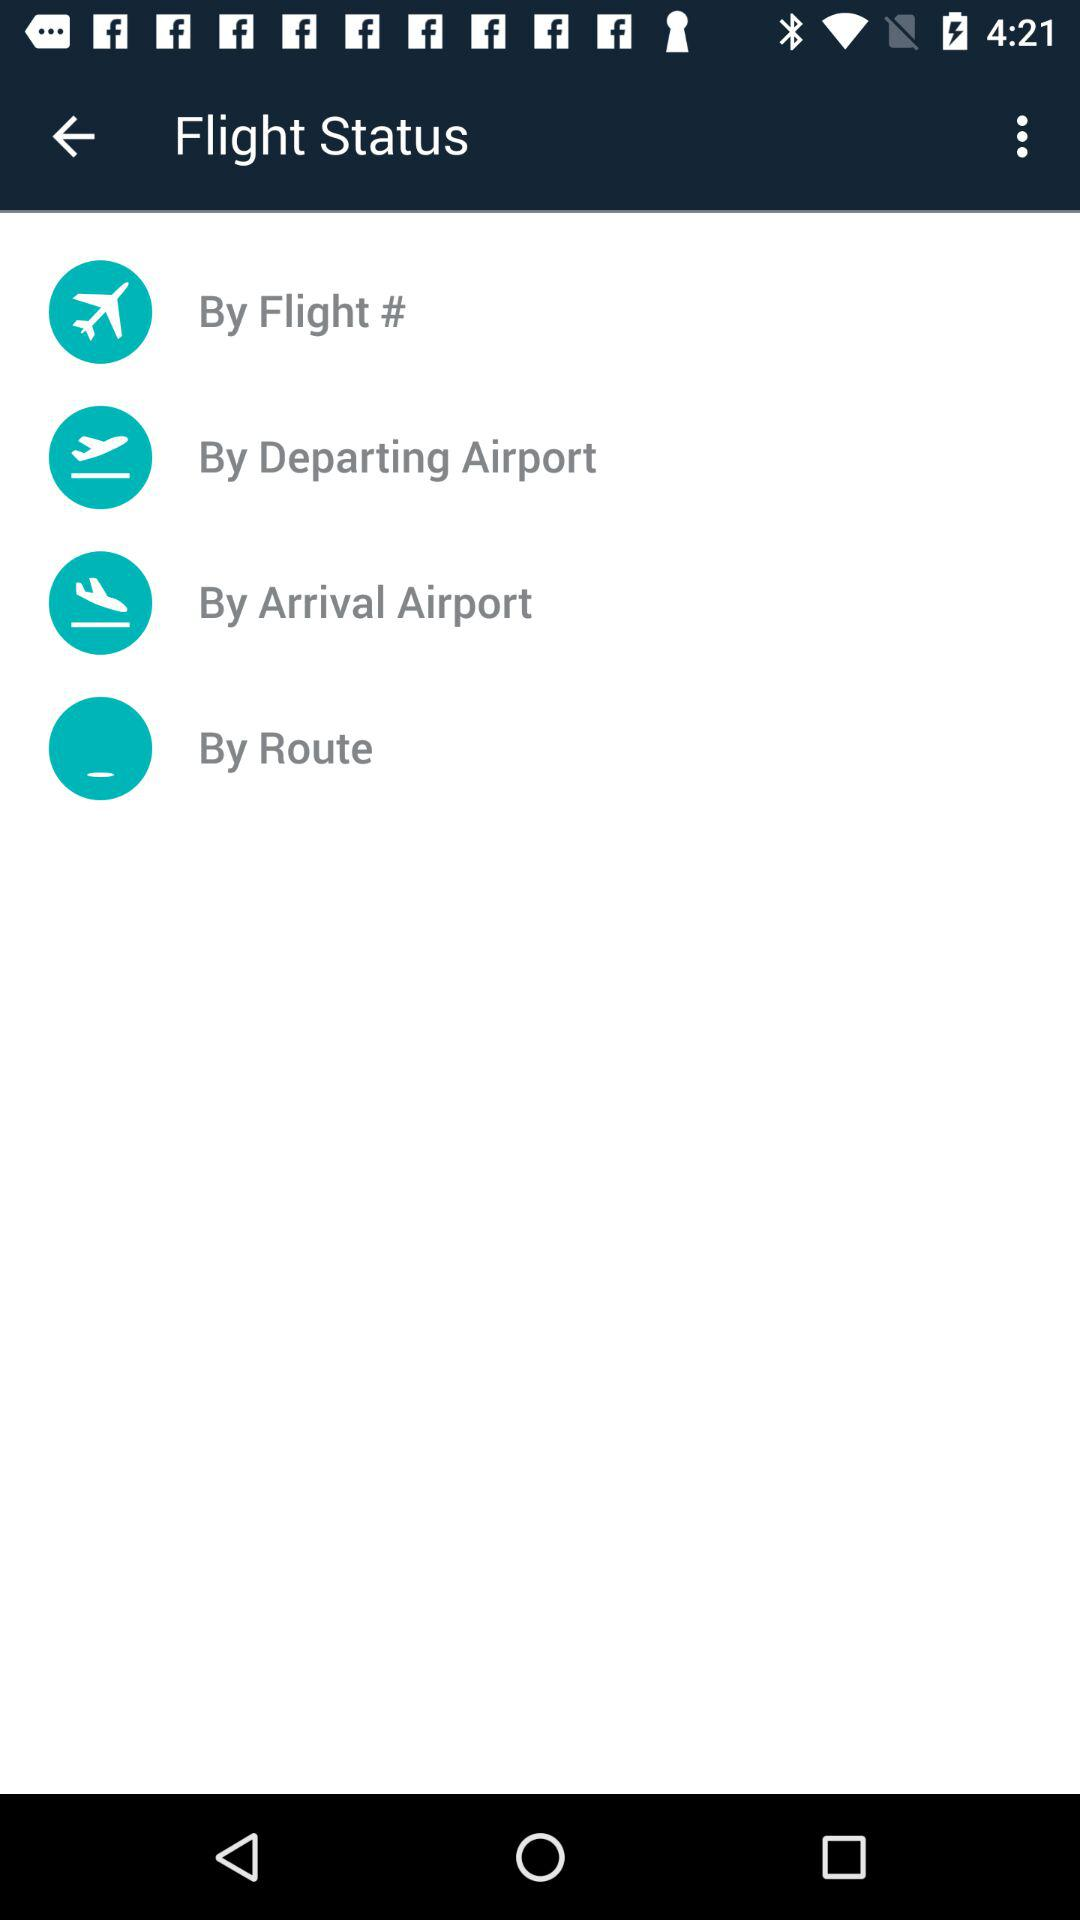What is the application name?
When the provided information is insufficient, respond with <no answer>. <no answer> 